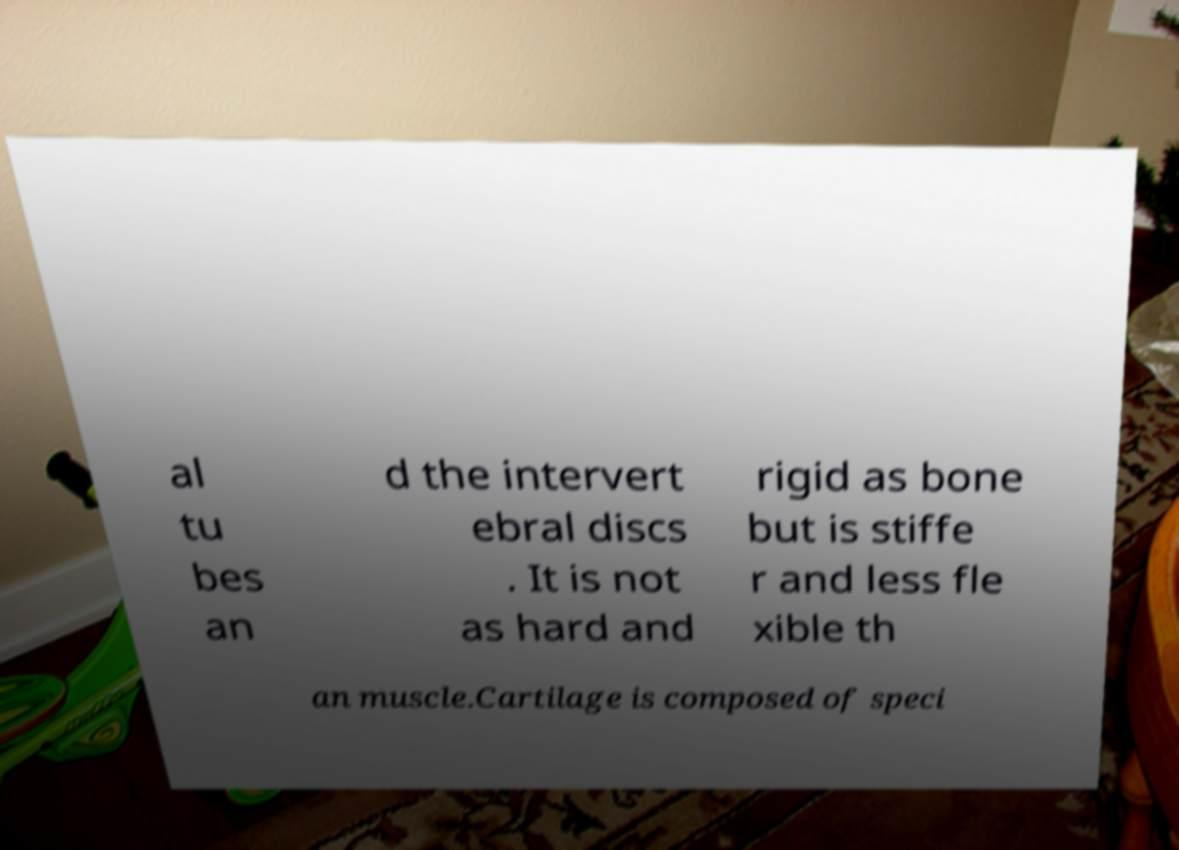There's text embedded in this image that I need extracted. Can you transcribe it verbatim? al tu bes an d the intervert ebral discs . It is not as hard and rigid as bone but is stiffe r and less fle xible th an muscle.Cartilage is composed of speci 